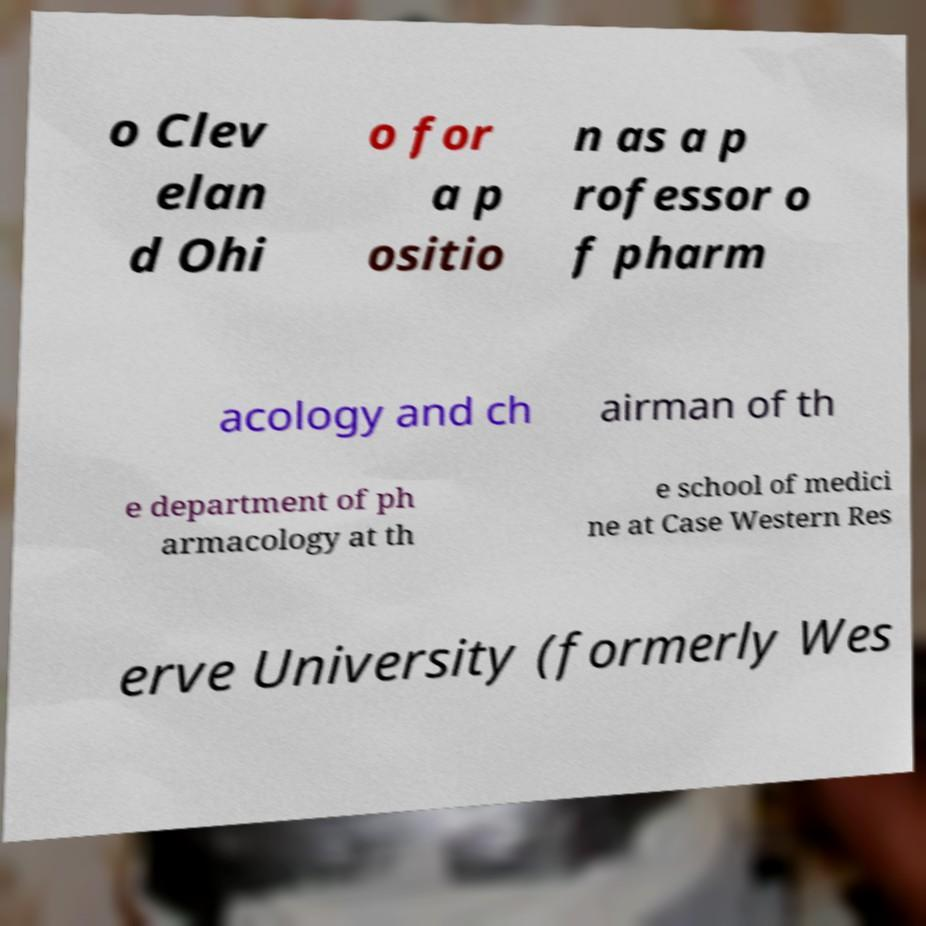What messages or text are displayed in this image? I need them in a readable, typed format. o Clev elan d Ohi o for a p ositio n as a p rofessor o f pharm acology and ch airman of th e department of ph armacology at th e school of medici ne at Case Western Res erve University (formerly Wes 